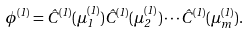<formula> <loc_0><loc_0><loc_500><loc_500>\phi ^ { ( 1 ) } = \hat { C } ^ { ( 1 ) } ( \mu ^ { ( 1 ) } _ { 1 } ) \hat { C } ^ { ( 1 ) } ( \mu ^ { ( 1 ) } _ { 2 } ) \cdots \hat { C } ^ { ( 1 ) } ( \mu ^ { ( 1 ) } _ { m } ) .</formula> 